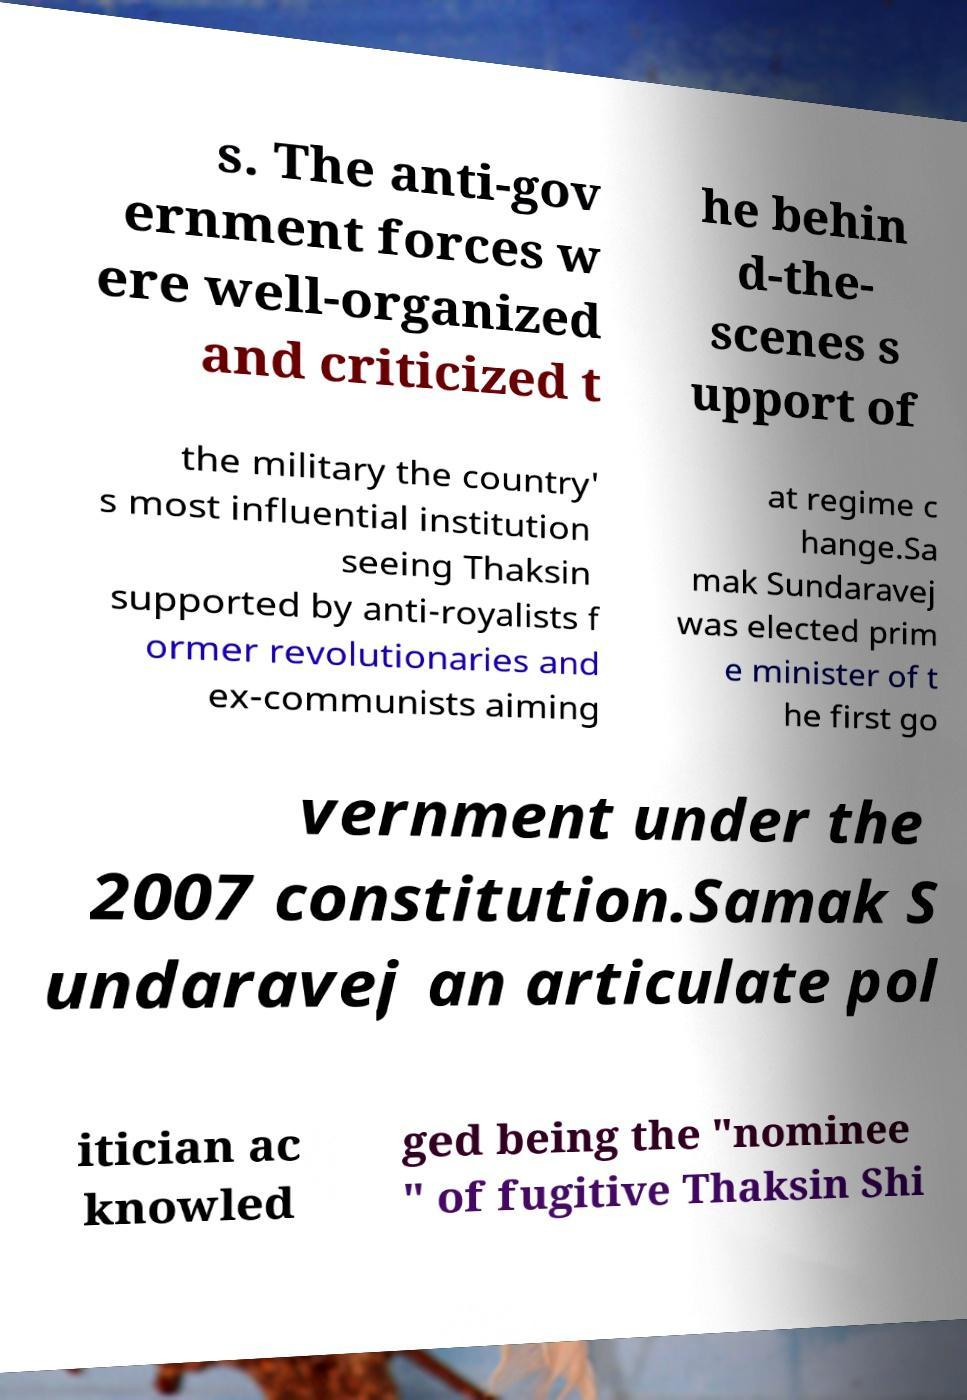Can you read and provide the text displayed in the image?This photo seems to have some interesting text. Can you extract and type it out for me? s. The anti-gov ernment forces w ere well-organized and criticized t he behin d-the- scenes s upport of the military the country' s most influential institution seeing Thaksin supported by anti-royalists f ormer revolutionaries and ex-communists aiming at regime c hange.Sa mak Sundaravej was elected prim e minister of t he first go vernment under the 2007 constitution.Samak S undaravej an articulate pol itician ac knowled ged being the "nominee " of fugitive Thaksin Shi 